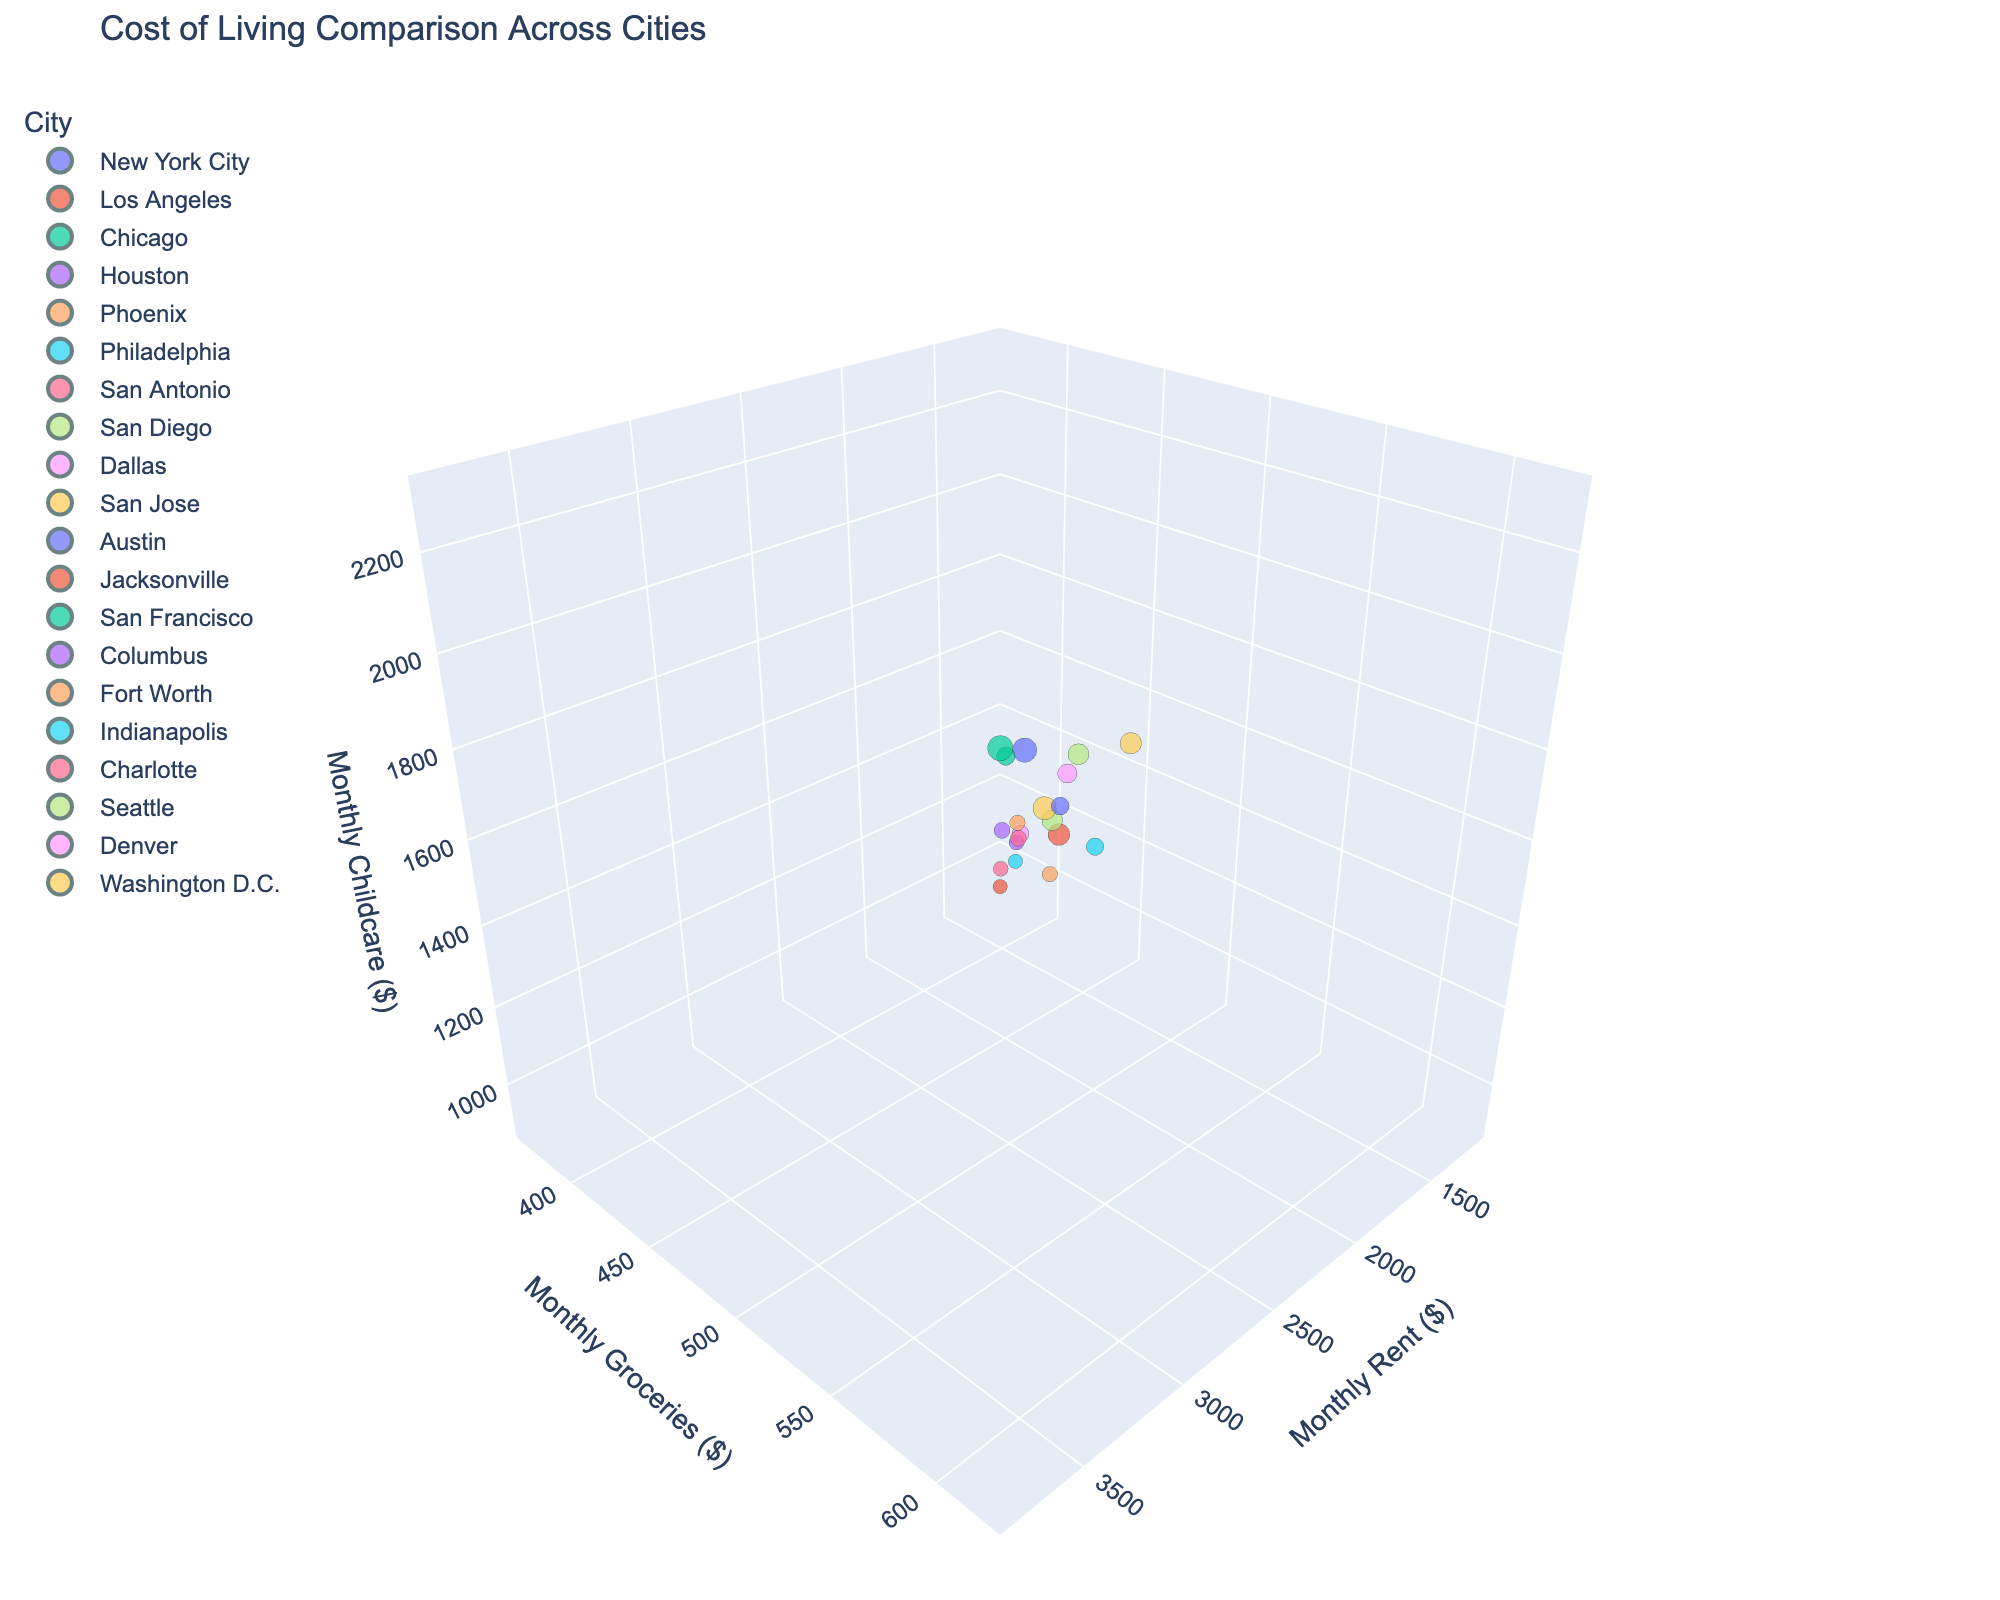What is the city with the highest monthly rent? By inspecting the plot, the highest value on the x-axis representing "Monthly Rent ($)" is $3800, which corresponds to San Francisco.
Answer: San Francisco Which city has the lowest monthly childcare cost? By observing the lowest point on the z-axis representing "Monthly Childcare ($)", the lowest value is $900, which corresponds to Jacksonville.
Answer: Jacksonville How do rent prices in San Diego compare to those in Seattle? Looking at the x-axis values for "Monthly Rent ($)", San Diego has a rent price of $2500, whereas Seattle's rent price is $2600. Therefore, Seattle's rent is slightly higher than San Diego's.
Answer: Seattle has higher rent Which two cities have the most similar monthly groceries expenses and how much is the difference? Observing the y-axis values, Houston and Fort Worth both have groceries expenses around $400 per month. The exact values are Houston at $400 and Fort Worth at $400, making the difference $0.
Answer: Houston and Fort Worth, $0 If your monthly rent budget is around $1500, which cities fit that range? By looking at the x-axis values around $1500, the cities that fit this range are Houston, Fort Worth, and Charlotte.
Answer: Houston, Fort Worth, and Charlotte What is the overall trend between rent prices and childcare costs? By inspecting the plot, it can be observed that as rent prices (x-axis) increase, childcare costs (z-axis) also tend to increase. This shows a positive correlation.
Answer: Positive correlation Which city has a higher overall cost combining rent, groceries, and childcare, New York City or San Francisco? Summing up the values for New York City: $3500 (rent) + $600 (groceries) + $2200 (childcare) = $6300. Summing up for San Francisco: $3800 (rent) + $620 (groceries) + $2300 (childcare) = $6720. Therefore, San Francisco has a higher overall cost.
Answer: San Francisco Are there any cities that fall below $1500 for both rent and childcare? By checking the x-axis and z-axis for values below $1500, the cities meeting this criterion are San Antonio, Columbus, Jacksonville, and Indianapolis.
Answer: San Antonio, Columbus, Jacksonville, and Indianapolis What is the relation between monthly groceries and monthly rent in Washington D.C.? In Washington D.C., the groceries expense is $570, and rent is $2700 as observed on their respective axes. These values show that groceries make up a much smaller portion relative to high rent costs.
Answer: Groceries much smaller relative to rent 